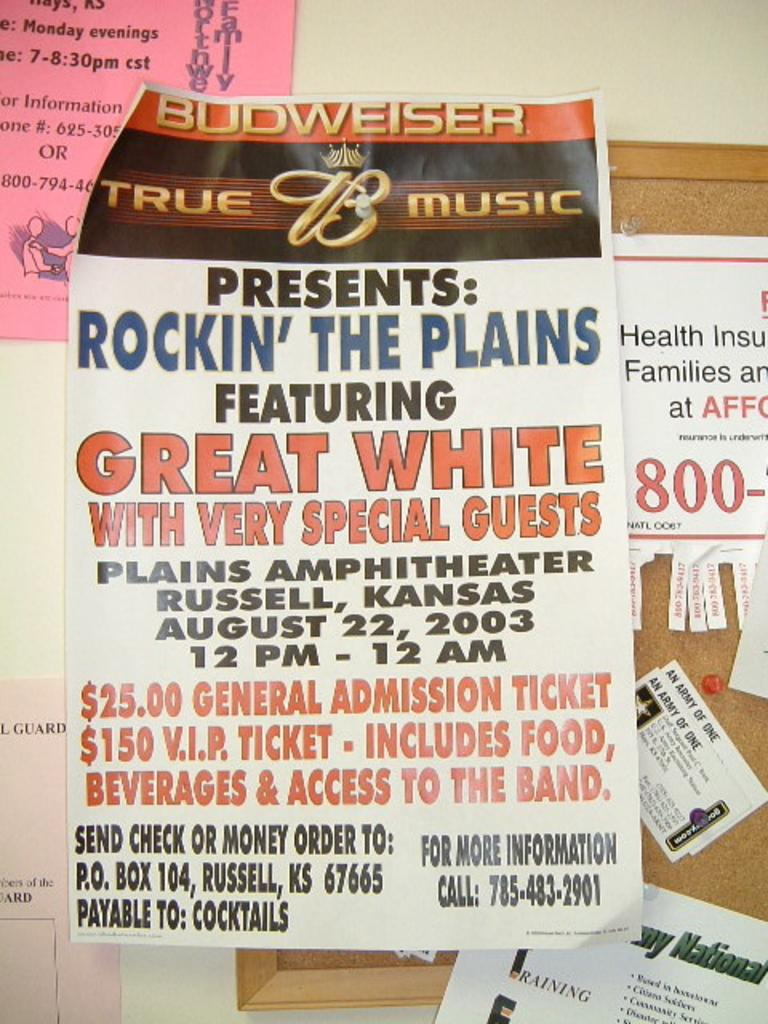<image>
Describe the image concisely. Poster showcasing a music group date time and price of tickets. 